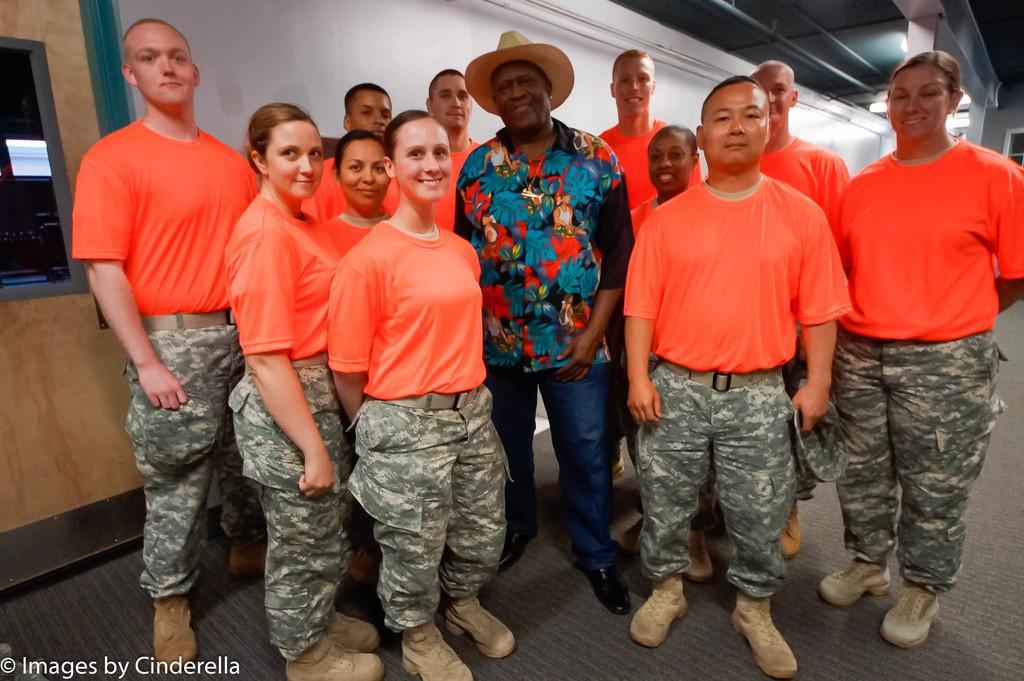In one or two sentences, can you explain what this image depicts? In this image we can see people standing. The man standing in the center is wearing a hat. In the background there is a wall and we can see a door. There are lights. 